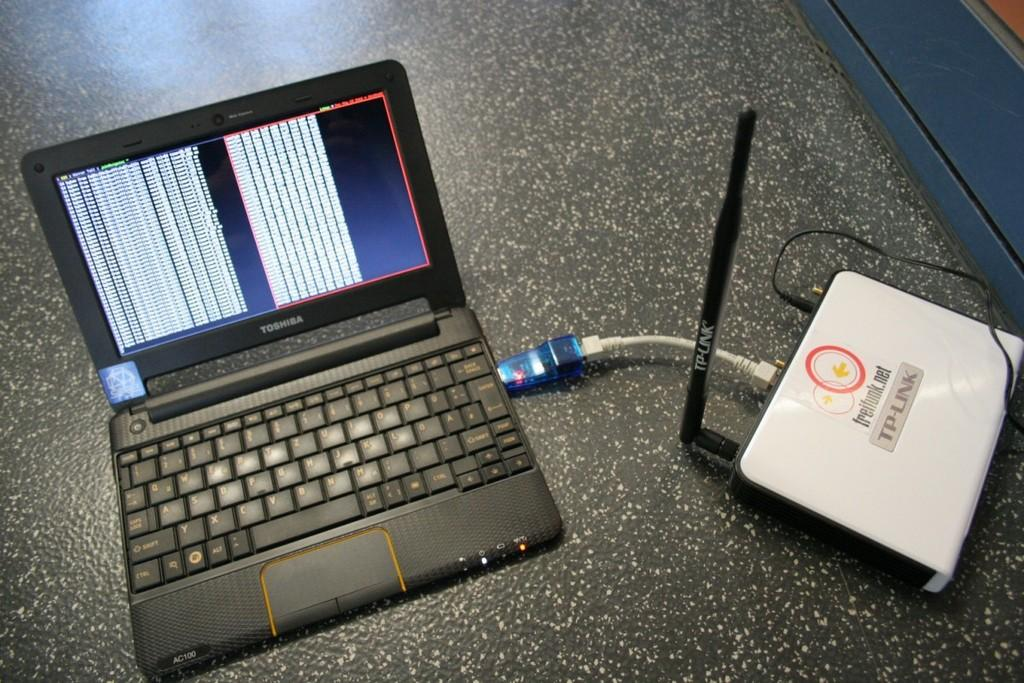<image>
Share a concise interpretation of the image provided. A laptop hooked up to a device reading TP-Link 